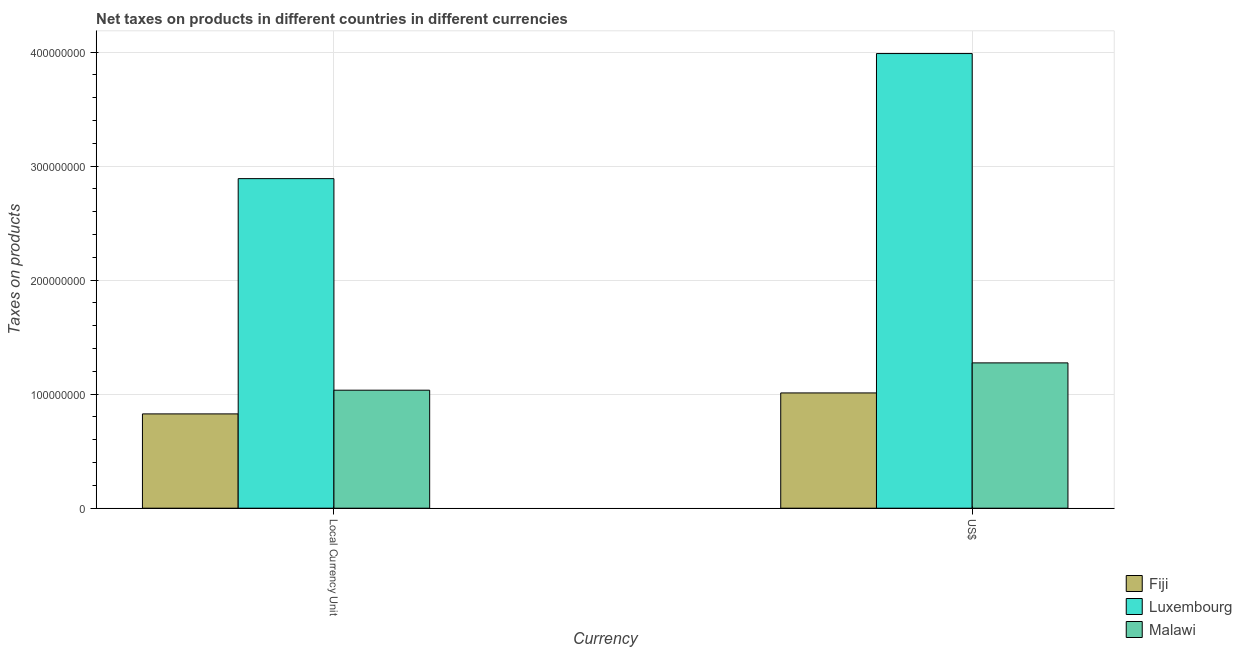How many groups of bars are there?
Provide a succinct answer. 2. How many bars are there on the 1st tick from the left?
Your answer should be very brief. 3. How many bars are there on the 1st tick from the right?
Offer a very short reply. 3. What is the label of the 2nd group of bars from the left?
Provide a succinct answer. US$. What is the net taxes in us$ in Luxembourg?
Your answer should be very brief. 3.99e+08. Across all countries, what is the maximum net taxes in us$?
Keep it short and to the point. 3.99e+08. Across all countries, what is the minimum net taxes in us$?
Keep it short and to the point. 1.01e+08. In which country was the net taxes in us$ maximum?
Provide a short and direct response. Luxembourg. In which country was the net taxes in us$ minimum?
Your response must be concise. Fiji. What is the total net taxes in us$ in the graph?
Provide a short and direct response. 6.27e+08. What is the difference between the net taxes in constant 2005 us$ in Malawi and that in Luxembourg?
Provide a short and direct response. -1.86e+08. What is the difference between the net taxes in constant 2005 us$ in Fiji and the net taxes in us$ in Luxembourg?
Provide a short and direct response. -3.16e+08. What is the average net taxes in constant 2005 us$ per country?
Offer a terse response. 1.58e+08. What is the difference between the net taxes in us$ and net taxes in constant 2005 us$ in Malawi?
Your answer should be very brief. 2.39e+07. In how many countries, is the net taxes in us$ greater than 80000000 units?
Make the answer very short. 3. What is the ratio of the net taxes in us$ in Malawi to that in Fiji?
Provide a succinct answer. 1.26. Is the net taxes in constant 2005 us$ in Fiji less than that in Malawi?
Your answer should be compact. Yes. In how many countries, is the net taxes in constant 2005 us$ greater than the average net taxes in constant 2005 us$ taken over all countries?
Your answer should be compact. 1. What does the 3rd bar from the left in US$ represents?
Your answer should be very brief. Malawi. What does the 3rd bar from the right in Local Currency Unit represents?
Your response must be concise. Fiji. How many bars are there?
Your answer should be compact. 6. Are all the bars in the graph horizontal?
Provide a short and direct response. No. Are the values on the major ticks of Y-axis written in scientific E-notation?
Your answer should be very brief. No. Does the graph contain any zero values?
Your answer should be very brief. No. Does the graph contain grids?
Your answer should be very brief. Yes. How many legend labels are there?
Provide a succinct answer. 3. What is the title of the graph?
Provide a succinct answer. Net taxes on products in different countries in different currencies. What is the label or title of the X-axis?
Keep it short and to the point. Currency. What is the label or title of the Y-axis?
Offer a terse response. Taxes on products. What is the Taxes on products in Fiji in Local Currency Unit?
Your response must be concise. 8.27e+07. What is the Taxes on products of Luxembourg in Local Currency Unit?
Offer a terse response. 2.89e+08. What is the Taxes on products in Malawi in Local Currency Unit?
Provide a succinct answer. 1.04e+08. What is the Taxes on products in Fiji in US$?
Provide a succinct answer. 1.01e+08. What is the Taxes on products in Luxembourg in US$?
Offer a very short reply. 3.99e+08. What is the Taxes on products of Malawi in US$?
Give a very brief answer. 1.27e+08. Across all Currency, what is the maximum Taxes on products of Fiji?
Your answer should be compact. 1.01e+08. Across all Currency, what is the maximum Taxes on products of Luxembourg?
Provide a succinct answer. 3.99e+08. Across all Currency, what is the maximum Taxes on products in Malawi?
Your response must be concise. 1.27e+08. Across all Currency, what is the minimum Taxes on products of Fiji?
Make the answer very short. 8.27e+07. Across all Currency, what is the minimum Taxes on products of Luxembourg?
Provide a short and direct response. 2.89e+08. Across all Currency, what is the minimum Taxes on products in Malawi?
Ensure brevity in your answer.  1.04e+08. What is the total Taxes on products of Fiji in the graph?
Ensure brevity in your answer.  1.84e+08. What is the total Taxes on products in Luxembourg in the graph?
Keep it short and to the point. 6.88e+08. What is the total Taxes on products of Malawi in the graph?
Your answer should be compact. 2.31e+08. What is the difference between the Taxes on products in Fiji in Local Currency Unit and that in US$?
Your answer should be very brief. -1.84e+07. What is the difference between the Taxes on products of Luxembourg in Local Currency Unit and that in US$?
Your answer should be very brief. -1.10e+08. What is the difference between the Taxes on products in Malawi in Local Currency Unit and that in US$?
Keep it short and to the point. -2.39e+07. What is the difference between the Taxes on products in Fiji in Local Currency Unit and the Taxes on products in Luxembourg in US$?
Keep it short and to the point. -3.16e+08. What is the difference between the Taxes on products of Fiji in Local Currency Unit and the Taxes on products of Malawi in US$?
Keep it short and to the point. -4.47e+07. What is the difference between the Taxes on products in Luxembourg in Local Currency Unit and the Taxes on products in Malawi in US$?
Provide a short and direct response. 1.62e+08. What is the average Taxes on products in Fiji per Currency?
Your answer should be very brief. 9.19e+07. What is the average Taxes on products in Luxembourg per Currency?
Your answer should be very brief. 3.44e+08. What is the average Taxes on products of Malawi per Currency?
Give a very brief answer. 1.15e+08. What is the difference between the Taxes on products in Fiji and Taxes on products in Luxembourg in Local Currency Unit?
Ensure brevity in your answer.  -2.06e+08. What is the difference between the Taxes on products in Fiji and Taxes on products in Malawi in Local Currency Unit?
Your answer should be very brief. -2.08e+07. What is the difference between the Taxes on products of Luxembourg and Taxes on products of Malawi in Local Currency Unit?
Provide a succinct answer. 1.86e+08. What is the difference between the Taxes on products in Fiji and Taxes on products in Luxembourg in US$?
Offer a very short reply. -2.98e+08. What is the difference between the Taxes on products in Fiji and Taxes on products in Malawi in US$?
Provide a succinct answer. -2.63e+07. What is the difference between the Taxes on products of Luxembourg and Taxes on products of Malawi in US$?
Ensure brevity in your answer.  2.71e+08. What is the ratio of the Taxes on products in Fiji in Local Currency Unit to that in US$?
Make the answer very short. 0.82. What is the ratio of the Taxes on products of Luxembourg in Local Currency Unit to that in US$?
Your answer should be compact. 0.72. What is the ratio of the Taxes on products of Malawi in Local Currency Unit to that in US$?
Provide a short and direct response. 0.81. What is the difference between the highest and the second highest Taxes on products of Fiji?
Your answer should be very brief. 1.84e+07. What is the difference between the highest and the second highest Taxes on products of Luxembourg?
Offer a very short reply. 1.10e+08. What is the difference between the highest and the second highest Taxes on products in Malawi?
Make the answer very short. 2.39e+07. What is the difference between the highest and the lowest Taxes on products in Fiji?
Offer a very short reply. 1.84e+07. What is the difference between the highest and the lowest Taxes on products in Luxembourg?
Your answer should be very brief. 1.10e+08. What is the difference between the highest and the lowest Taxes on products in Malawi?
Provide a short and direct response. 2.39e+07. 